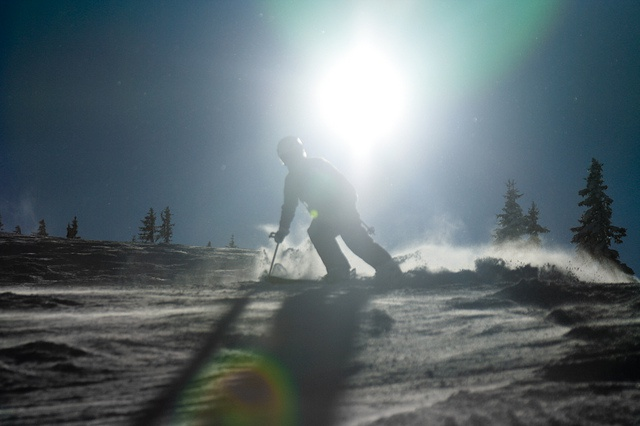Describe the objects in this image and their specific colors. I can see people in black, darkgray, gray, and lightgray tones and skis in black, gray, and darkgray tones in this image. 